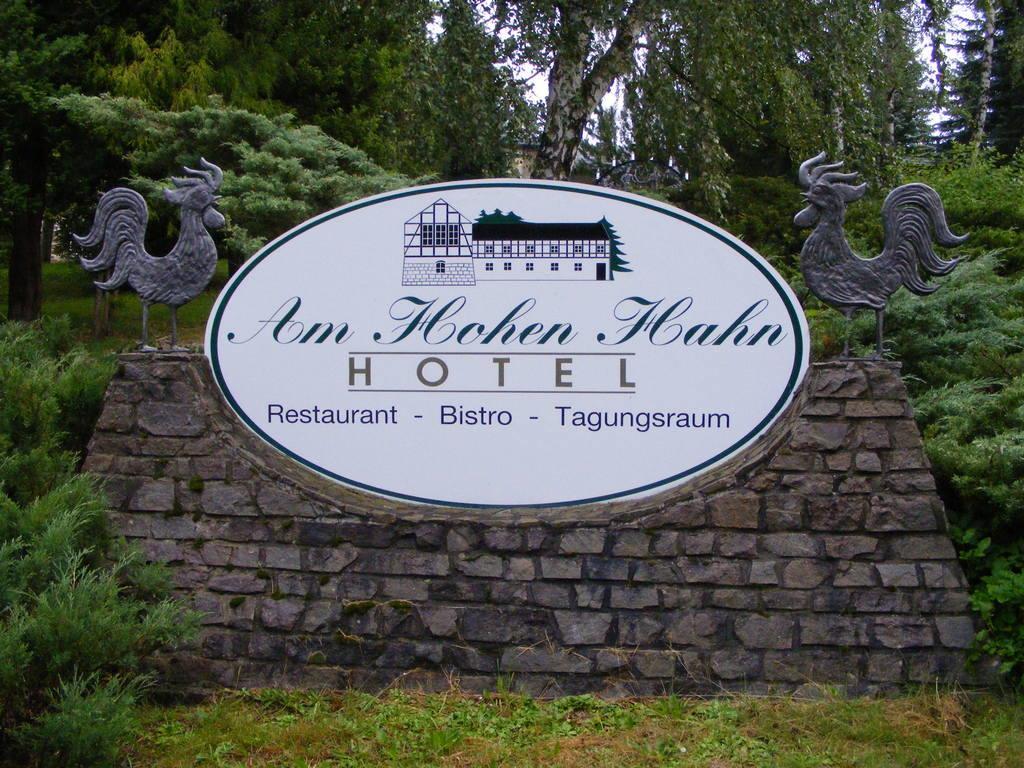Please provide a concise description of this image. In this image we can see many trees and few plants. There is a board in the image. There is some text on the board. We can see the sculpture of the birds. 